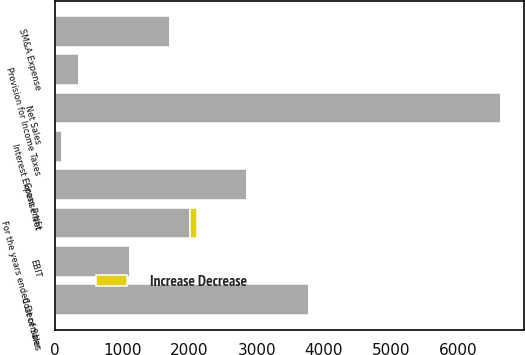<chart> <loc_0><loc_0><loc_500><loc_500><stacked_bar_chart><ecel><fcel>For the years ended December<fcel>Net Sales<fcel>Cost of Sales<fcel>Gross Profit<fcel>SM&A Expense<fcel>EBIT<fcel>Interest Expense Net<fcel>Provision for Income Taxes<nl><fcel>nan<fcel>2012<fcel>6644.3<fcel>3784.4<fcel>2859.9<fcel>1703.8<fcel>1111.1<fcel>95.6<fcel>354.6<nl><fcel>Increase Decrease<fcel>95.6<fcel>9.3<fcel>6.6<fcel>13<fcel>15.3<fcel>5.3<fcel>3.7<fcel>6.2<nl></chart> 